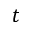Convert formula to latex. <formula><loc_0><loc_0><loc_500><loc_500>t</formula> 